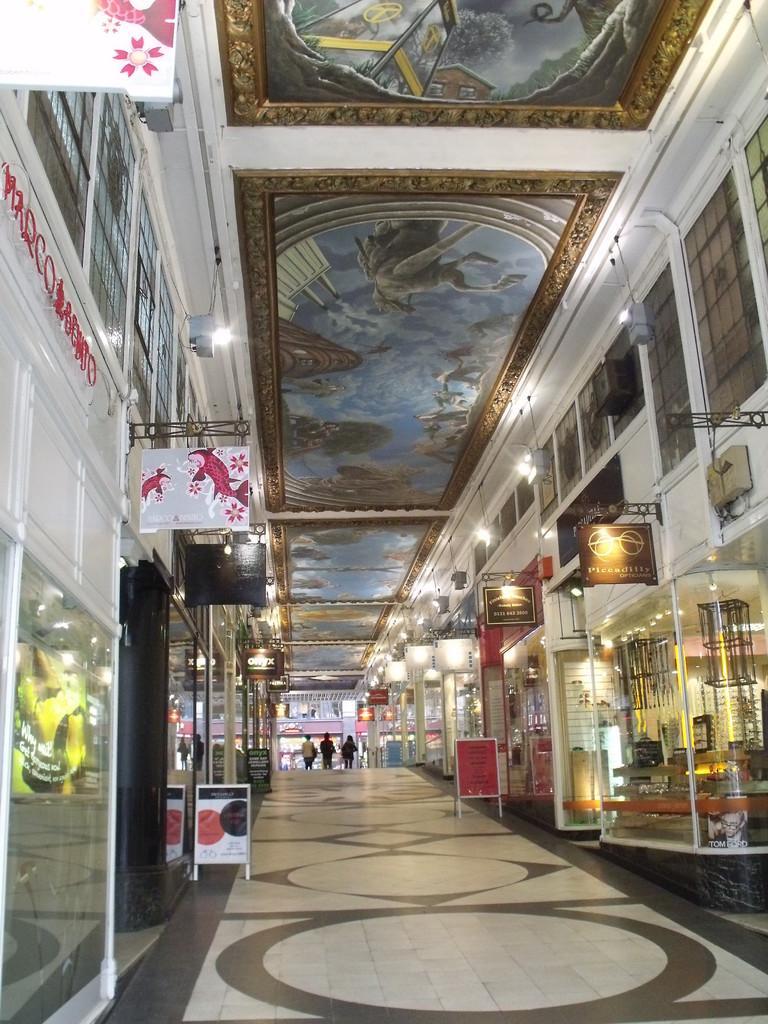Please provide a concise description of this image. In the image we can see some stores. Behind them few people are walking and there are some banners. At the top of the image there is ceiling, on the ceiling there are some lights and painting. 